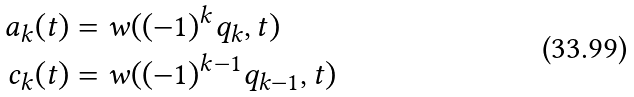<formula> <loc_0><loc_0><loc_500><loc_500>a _ { k } ( t ) & = w ( ( - 1 ) ^ { k } q _ { k } , t ) \\ c _ { k } ( t ) & = w ( ( - 1 ) ^ { k - 1 } q _ { k - 1 } , t )</formula> 